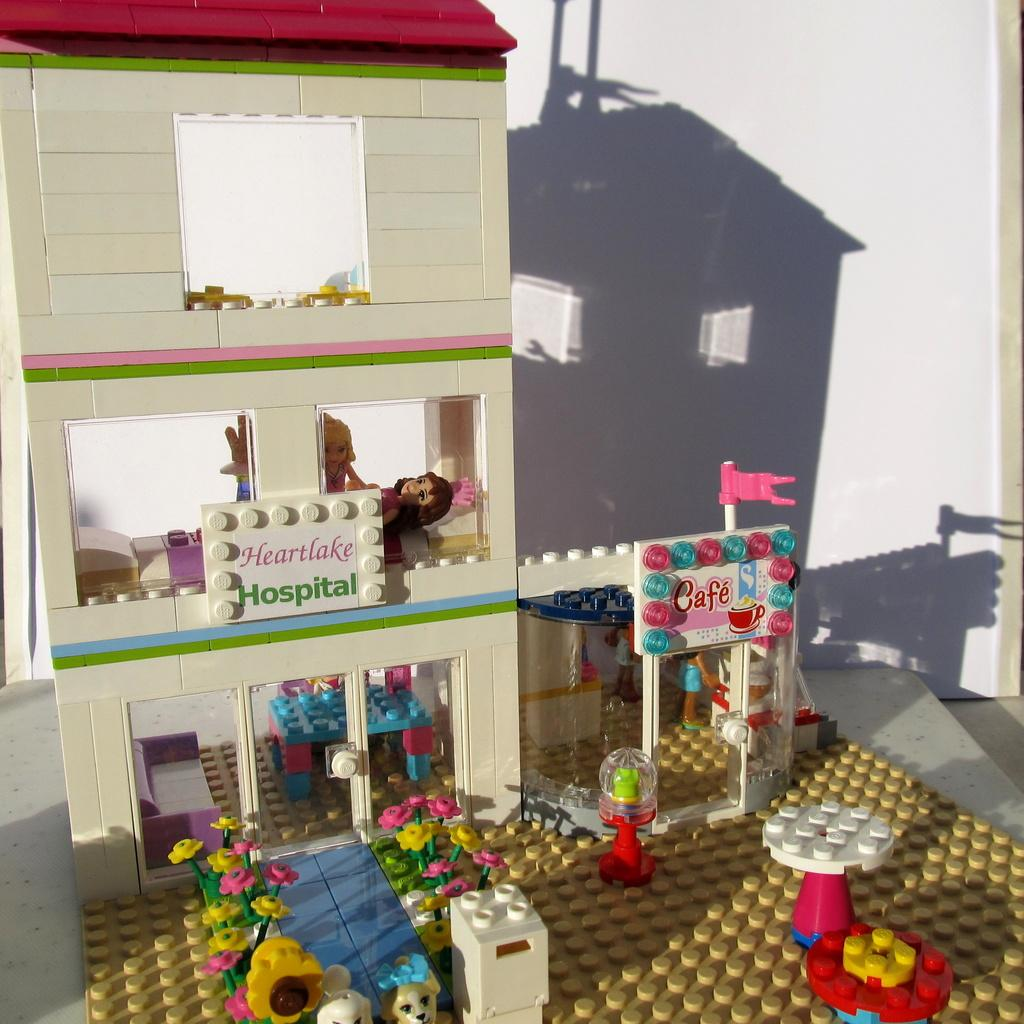What type of structure is visible in the image? There is a building in the image. What other objects can be seen in the image? There are toys, tables, and flowers visible in the image. Can you describe a unique feature of the image? There is a flag made of Lego in the image. What type of ray is swimming in the image? There is no ray present in the image; it features a building, toys, tables, flowers, and a Lego flag. 